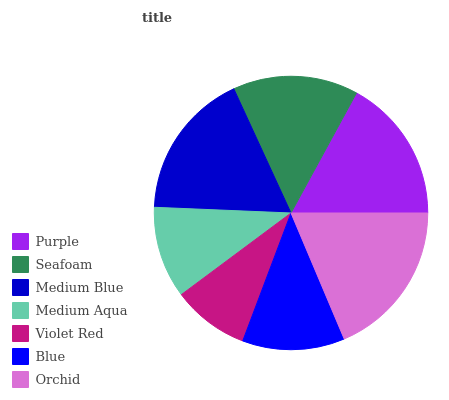Is Violet Red the minimum?
Answer yes or no. Yes. Is Orchid the maximum?
Answer yes or no. Yes. Is Seafoam the minimum?
Answer yes or no. No. Is Seafoam the maximum?
Answer yes or no. No. Is Purple greater than Seafoam?
Answer yes or no. Yes. Is Seafoam less than Purple?
Answer yes or no. Yes. Is Seafoam greater than Purple?
Answer yes or no. No. Is Purple less than Seafoam?
Answer yes or no. No. Is Seafoam the high median?
Answer yes or no. Yes. Is Seafoam the low median?
Answer yes or no. Yes. Is Medium Aqua the high median?
Answer yes or no. No. Is Medium Blue the low median?
Answer yes or no. No. 